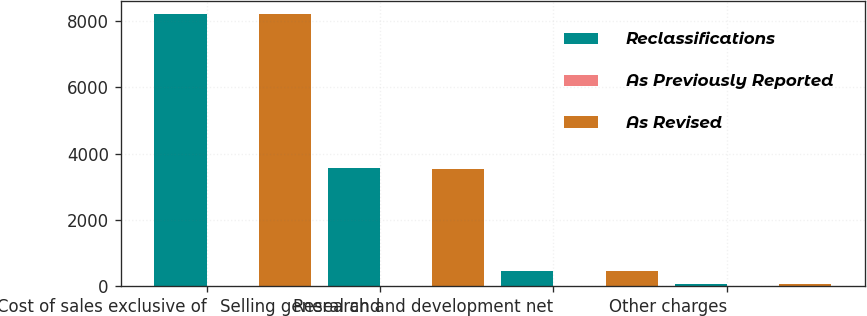<chart> <loc_0><loc_0><loc_500><loc_500><stacked_bar_chart><ecel><fcel>Cost of sales exclusive of<fcel>Selling general and<fcel>Research and development net<fcel>Other charges<nl><fcel>Reclassifications<fcel>8207<fcel>3564<fcel>453<fcel>64<nl><fcel>As Previously Reported<fcel>2<fcel>10<fcel>2<fcel>10<nl><fcel>As Revised<fcel>8209<fcel>3554<fcel>451<fcel>74<nl></chart> 